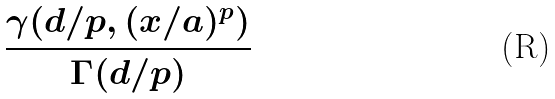Convert formula to latex. <formula><loc_0><loc_0><loc_500><loc_500>\frac { \gamma ( d / p , ( x / a ) ^ { p } ) } { \Gamma ( d / p ) }</formula> 